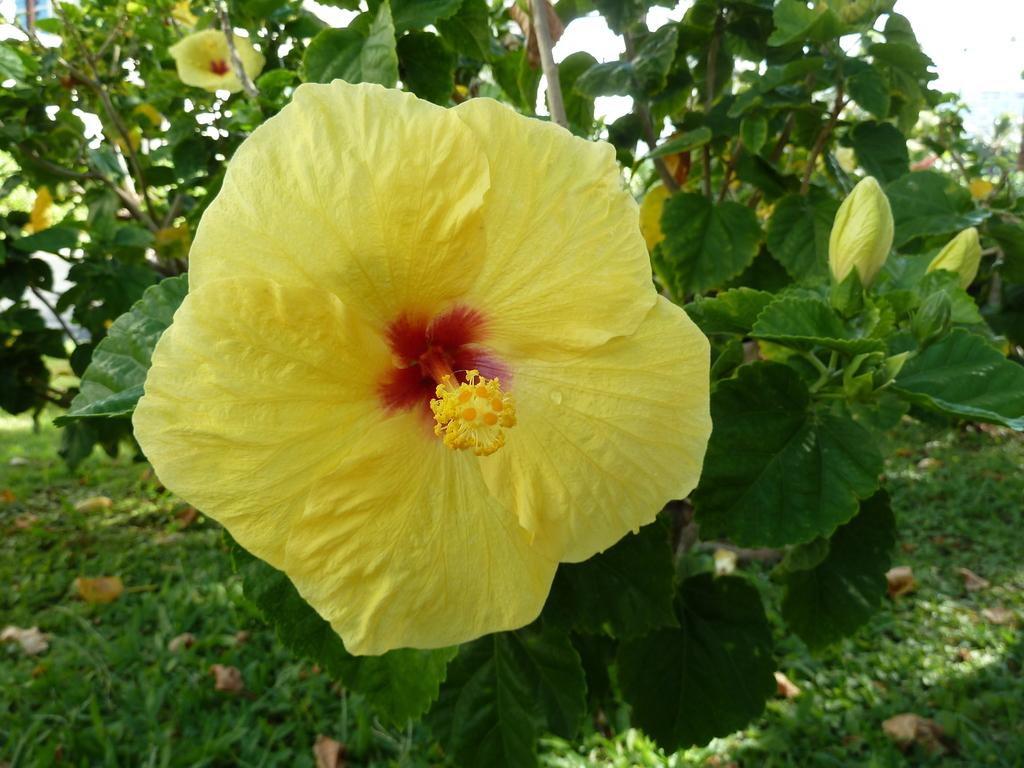What type of flowers are present in the image? There are yellow flowers in the image. What color are the leaves in the image? There are green leaves in the image. What type of vegetation is visible in the image? There is grass in the image. Where is the bucket located in the image? There is no bucket present in the image. What type of trail can be seen in the image? There is no trail present in the image. 